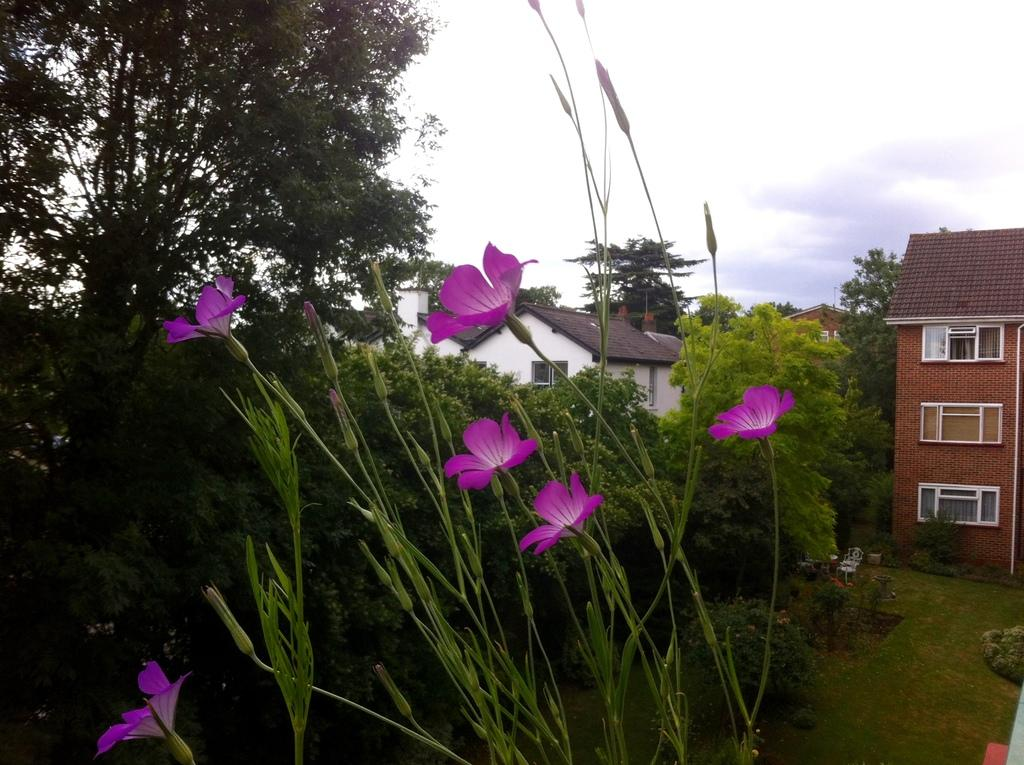What type of structures can be seen in the image? There are buildings in the image. What other natural elements are present in the image? There are trees and plants visible in the image. Are there any flowers in the image? Yes, flowers are visible in the image. What can be seen in the background of the image? There is sky visible in the background of the image. What type of peace treaty is being signed in the image? There is no indication of a peace treaty or any signing event in the image. 